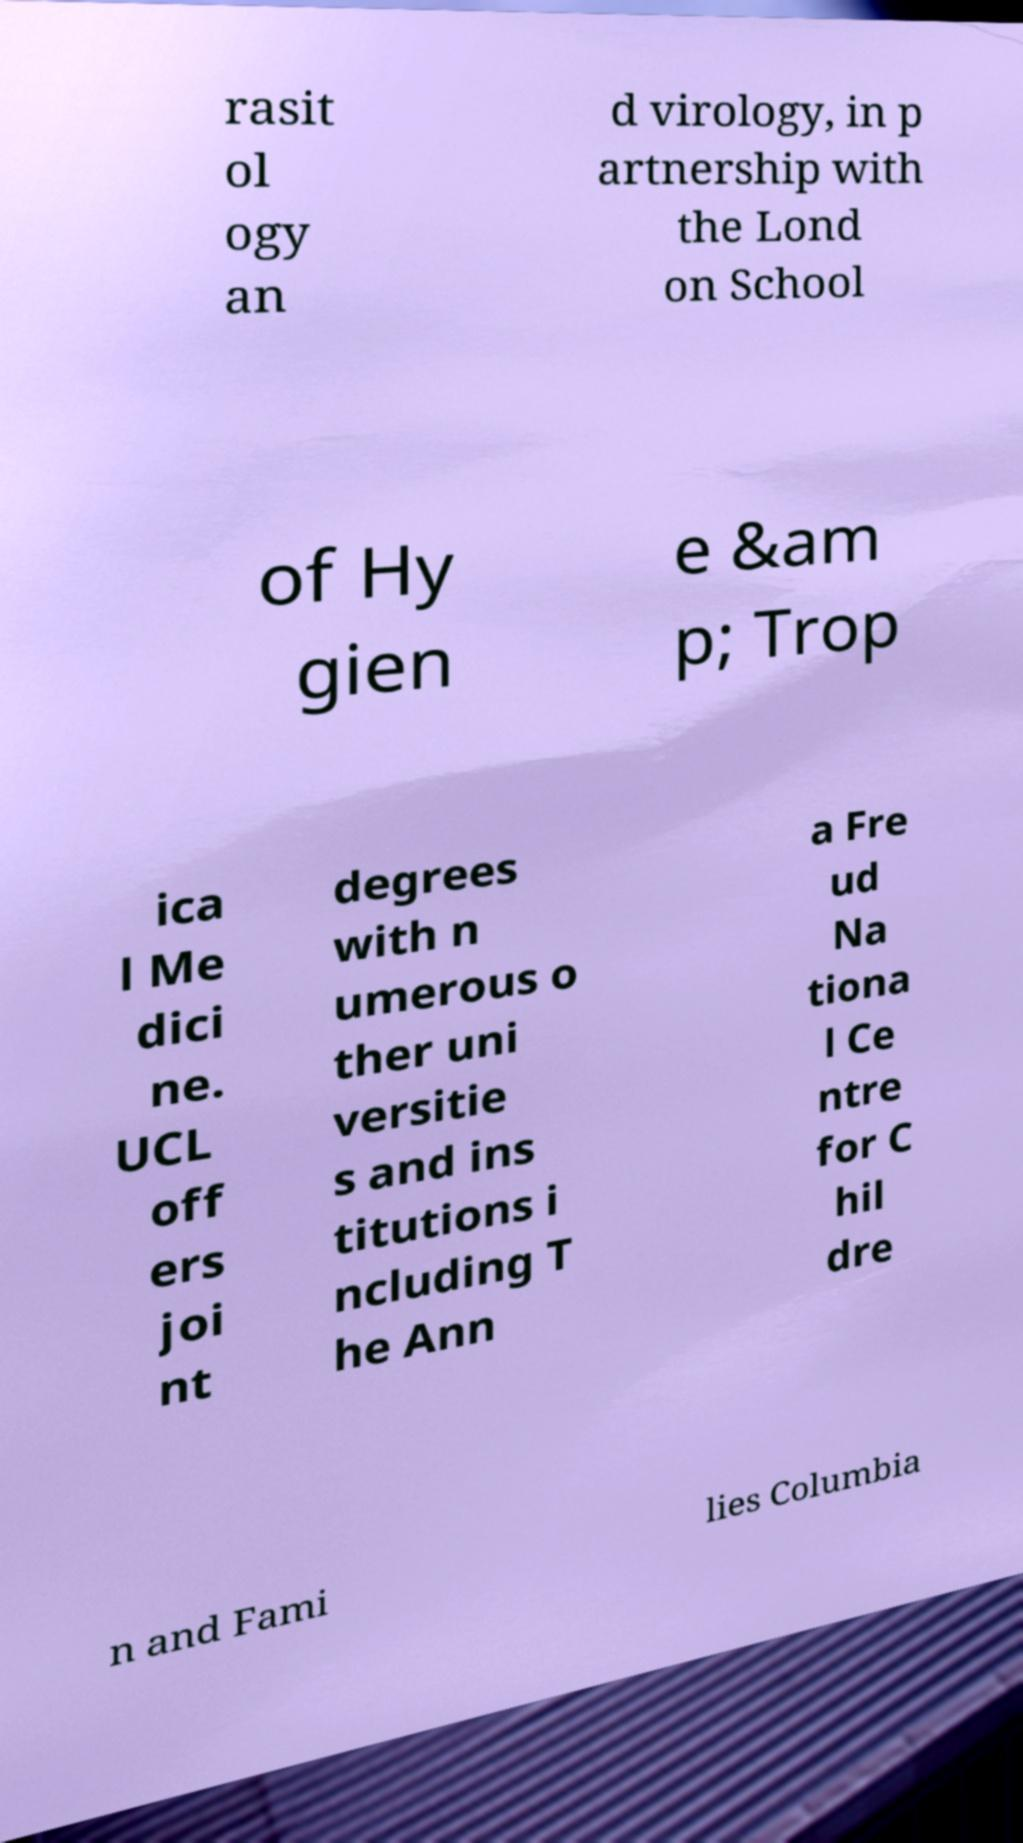Could you extract and type out the text from this image? rasit ol ogy an d virology, in p artnership with the Lond on School of Hy gien e &am p; Trop ica l Me dici ne. UCL off ers joi nt degrees with n umerous o ther uni versitie s and ins titutions i ncluding T he Ann a Fre ud Na tiona l Ce ntre for C hil dre n and Fami lies Columbia 